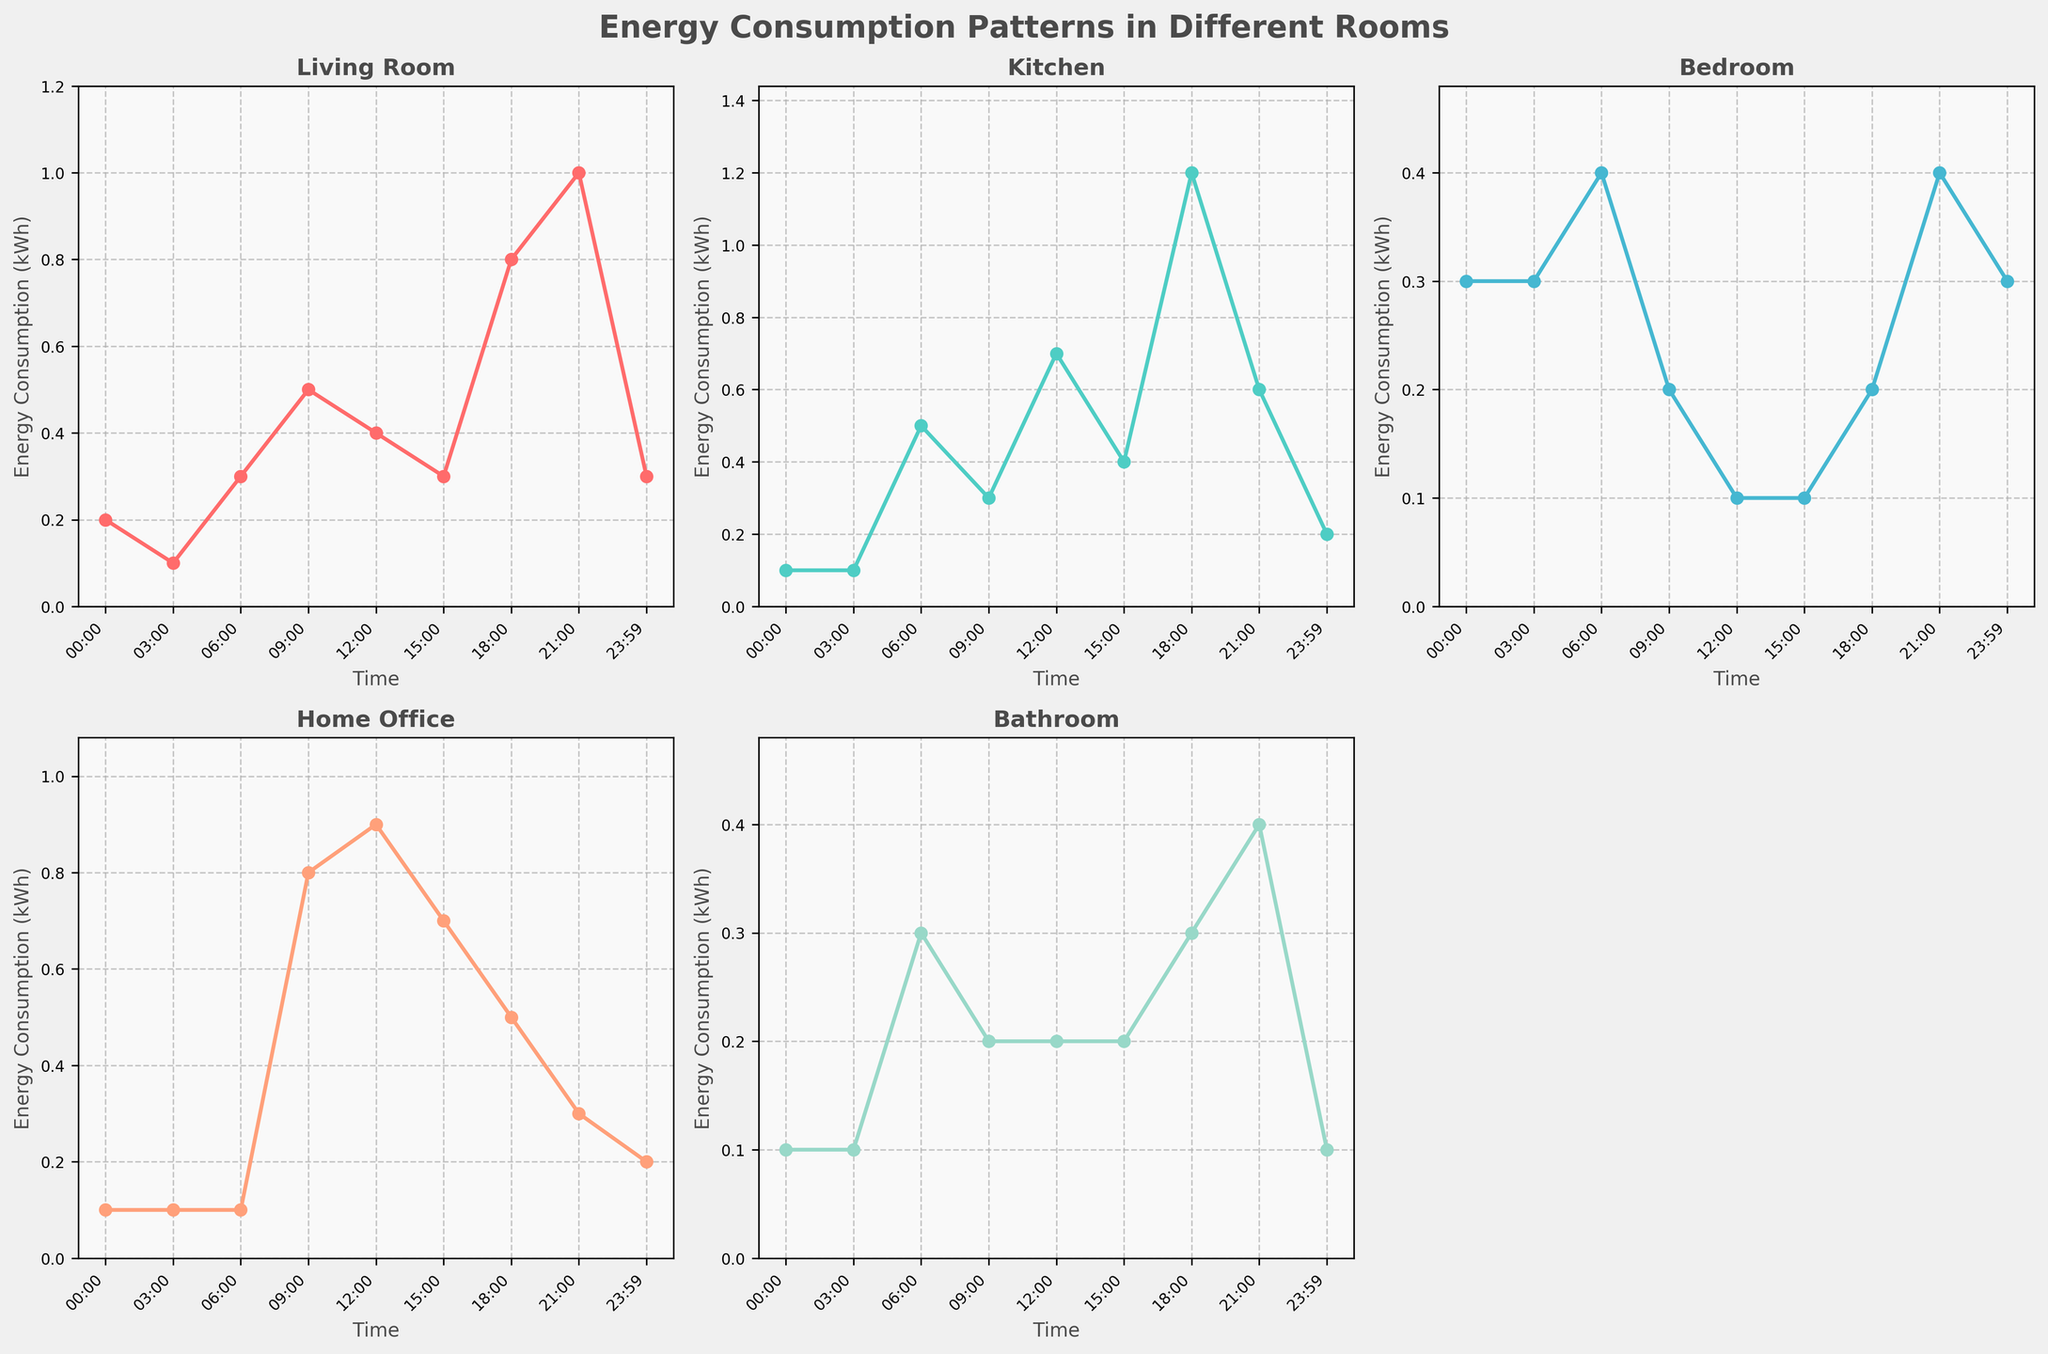What is the title of the figure? The title of the figure is displayed at the top in bold. It reads 'Energy Consumption Patterns in Different Rooms'.
Answer: Energy Consumption Patterns in Different Rooms What times are displayed on the x-axis? The x-axis displays times from 00:00 to 23:59 at various intervals such as 00:00, 03:00, 06:00, 09:00, 12:00, 15:00, 18:00, 21:00, and 23:59.
Answer: 00:00, 03:00, 06:00, 09:00, 12:00, 15:00, 18:00, 21:00, 23:59 Which room shows the highest energy consumption at 18:00? At 18:00, the Kitchen plot shows the highest energy consumption. The figure indicates the Kitchen's line peaks at this time with energy consumption around 1.2 kWh.
Answer: Kitchen What is the energy consumption of the Home Office at 09:00? At 09:00, the subplot for the Home Office shows a peak, indicating the energy consumption value of 0.8 kWh.
Answer: 0.8 kWh Which room has the least energy consumption at 21:00 and what is the value? At 21:00, the Home Office shows the least energy consumption. The plot for this time and room is at 0.3 kWh.
Answer: Home Office, 0.3 kWh During which time period does the Bedroom have a consistent energy consumption? The Bedroom shows a consistent energy consumption of around 0.3 kWh at multiple times like 00:00, 03:00, and 23:59.
Answer: 00:00, 03:00, 23:59 Compare the peak energy consumption times between the Living Room and Kitchen. The Living Room peaks at 21:00 with a consumption of 1.0 kWh, while the Kitchen peaks at 18:00 with a consumption of 1.2 kWh.
Answer: Living Room: 21:00, Kitchen: 18:00 What is the average energy consumption of the Bathroom over the displayed times? The Bathroom’s energy consumption values are 0.1, 0.1, 0.3, 0.2, 0.2, 0.2, 0.3, 0.4, 0.1 kWh respectively. Summing these gives 1.9 and dividing by 9 gives the average of approximately 0.211 kWh.
Answer: ~0.211 kWh Which room has the greatest variation in energy consumption throughout the day? The Kitchen shows the greatest variation in energy consumption, ranging from 0.1 kWh to 1.2 kWh, as evidenced by the subplot with the largest difference between its minimum and maximum values.
Answer: Kitchen 